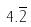<formula> <loc_0><loc_0><loc_500><loc_500>4 . \overline { 2 }</formula> 